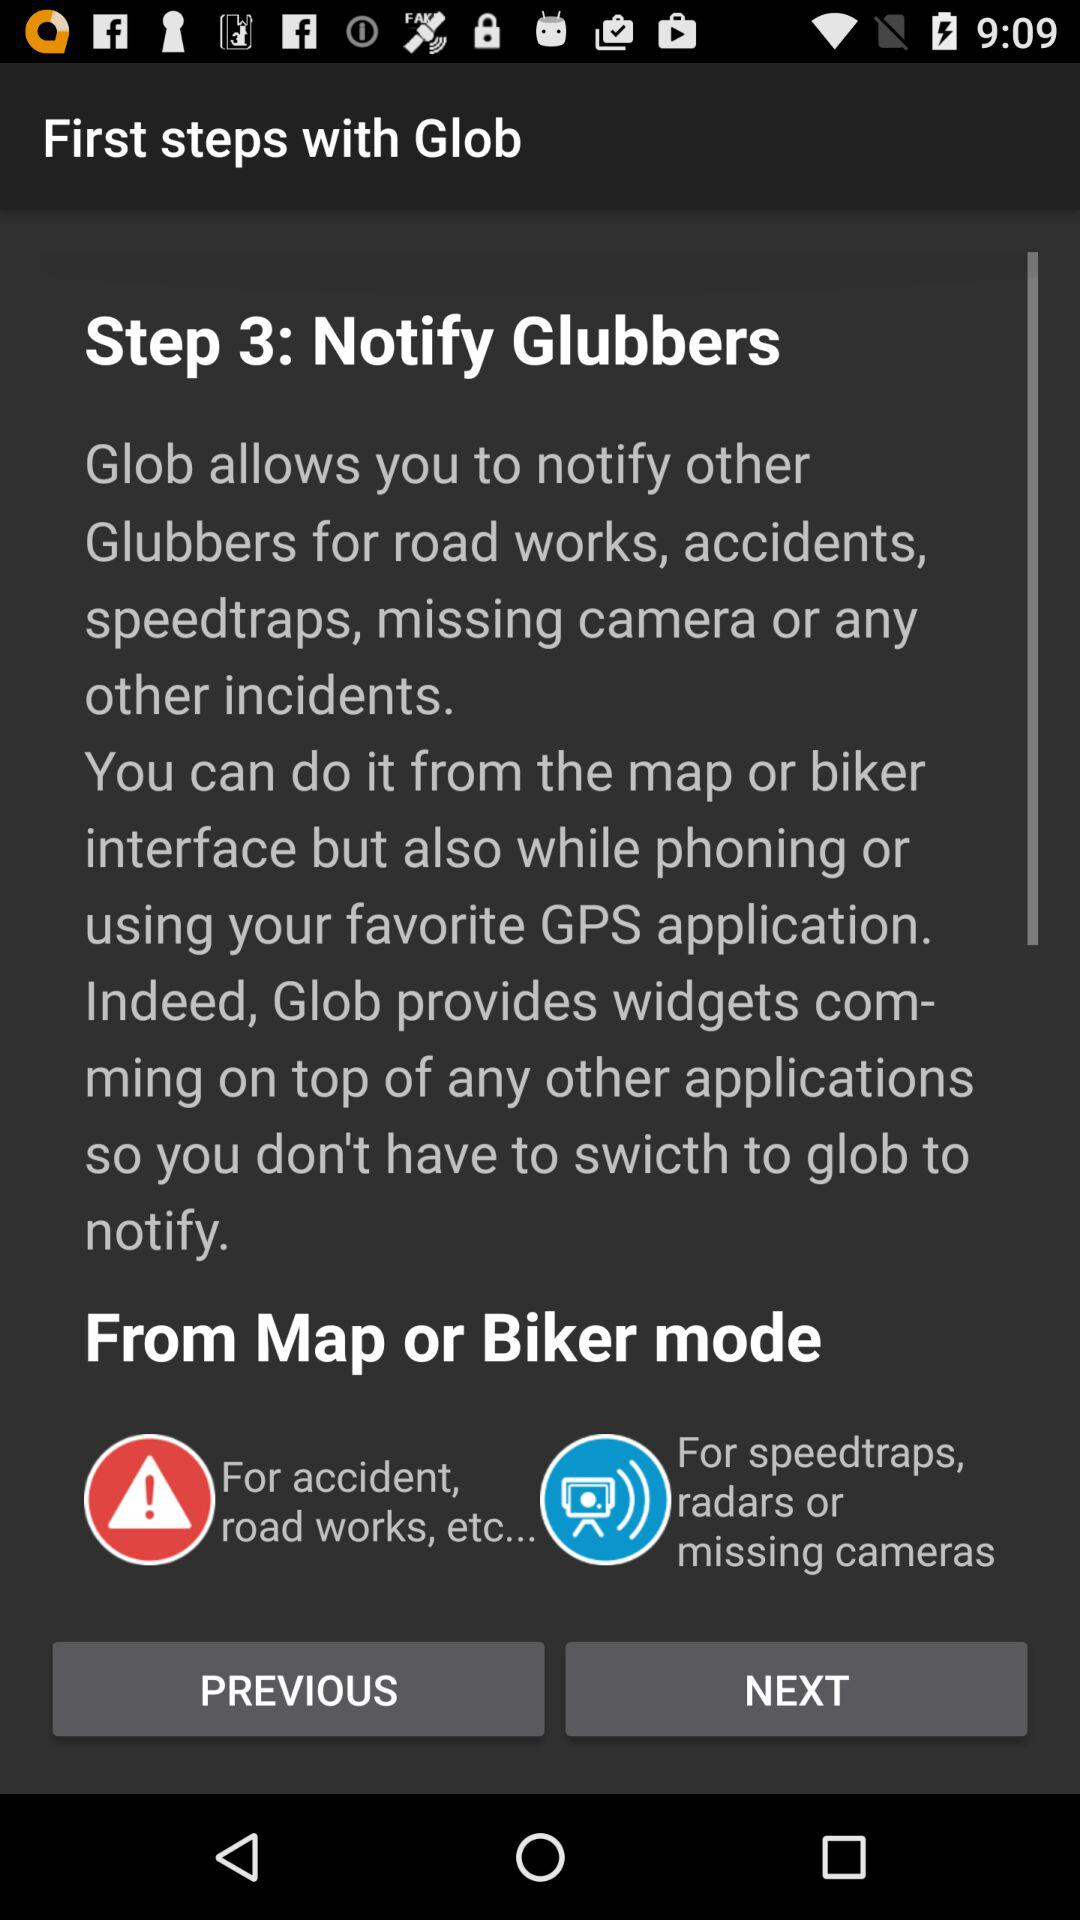What are the modes available on the map? The available modes are "Map" and "Biker". 